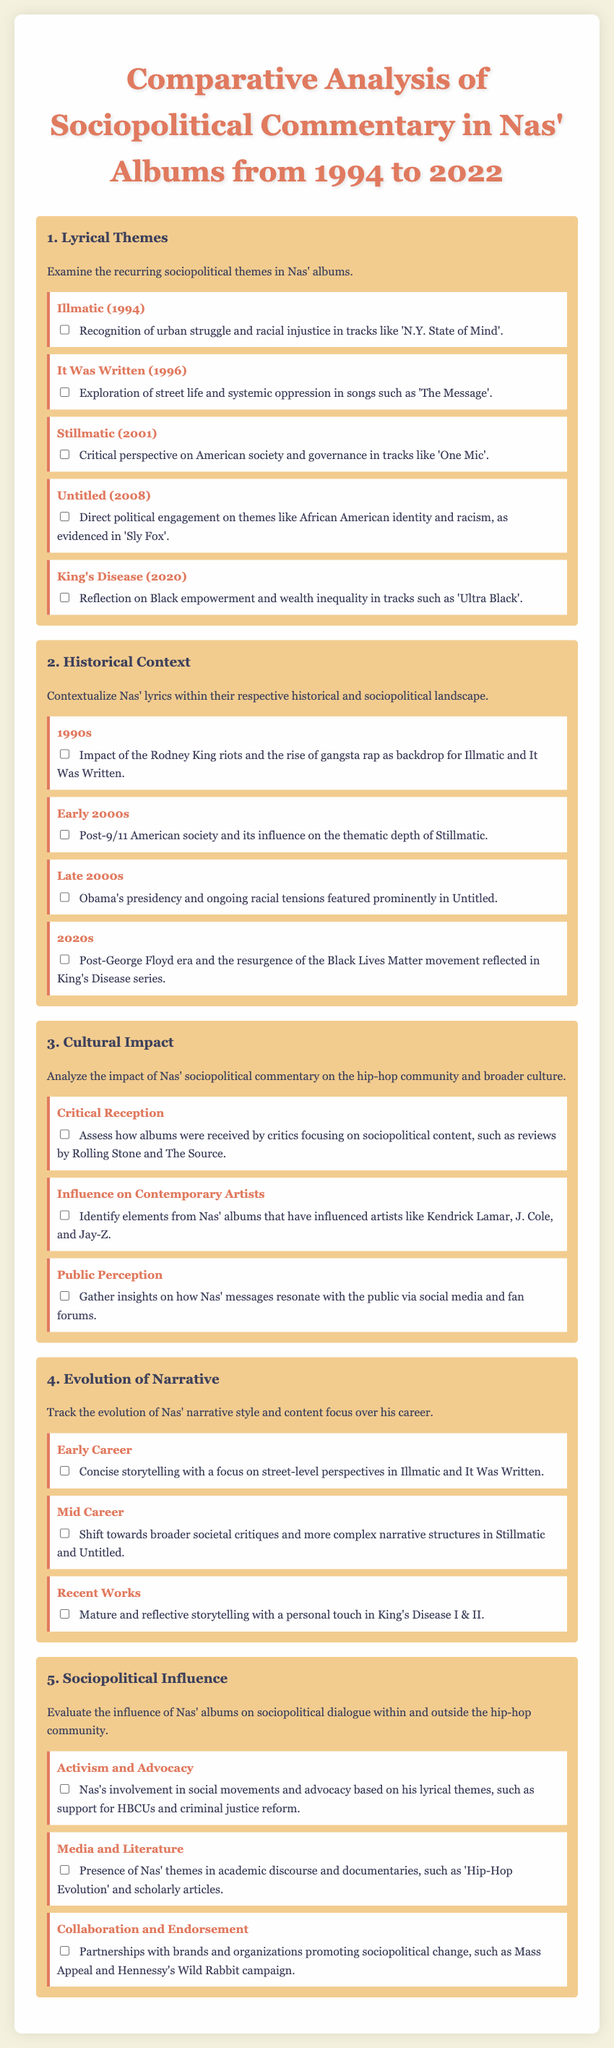What is the title of the first album discussed in the checklist? The first album discussed is under the Lyrical Themes section, where Illmatic is featured as the first album released in 1994.
Answer: Illmatic Which sociopolitical theme is highlighted in tracks from Untitled? The sub-item for Untitled states it addresses direct political engagement on African American identity and racism.
Answer: African American identity and racism How many albums are listed in the Lyrical Themes section? The Lyrical Themes section contains five sub-items, each representing a different album from various years.
Answer: Five In which decade did the Rodney King riots occur, as referenced in the Historical Context section? The checklist states that the impact of the Rodney King riots is contextualized in the 1990s section under Historical Context.
Answer: 1990s What social movement is mentioned in relation to Nas' activism? The Sociopolitical Influence section references Nas's support for HBCUs and criminal justice reform among social movements.
Answer: Black Lives Matter 